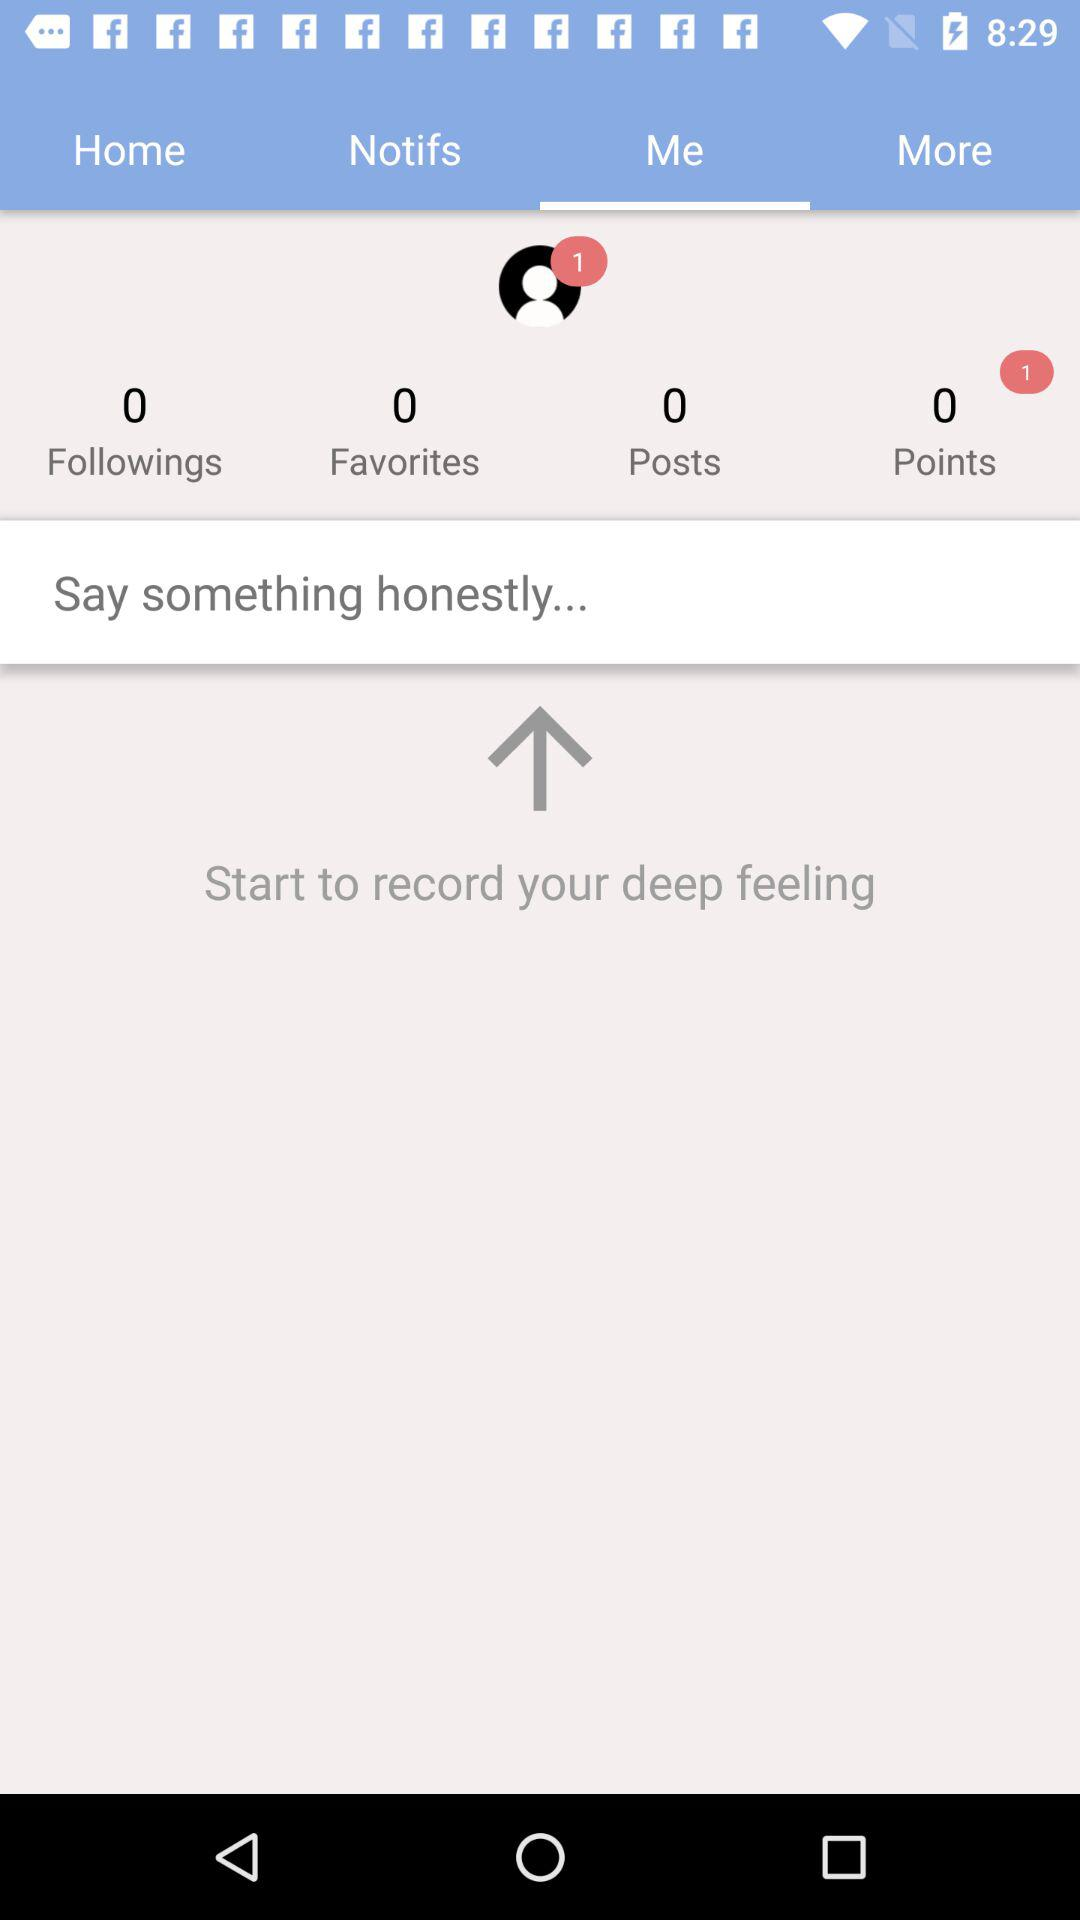What is the selected tab? The selected tab is "Me". 